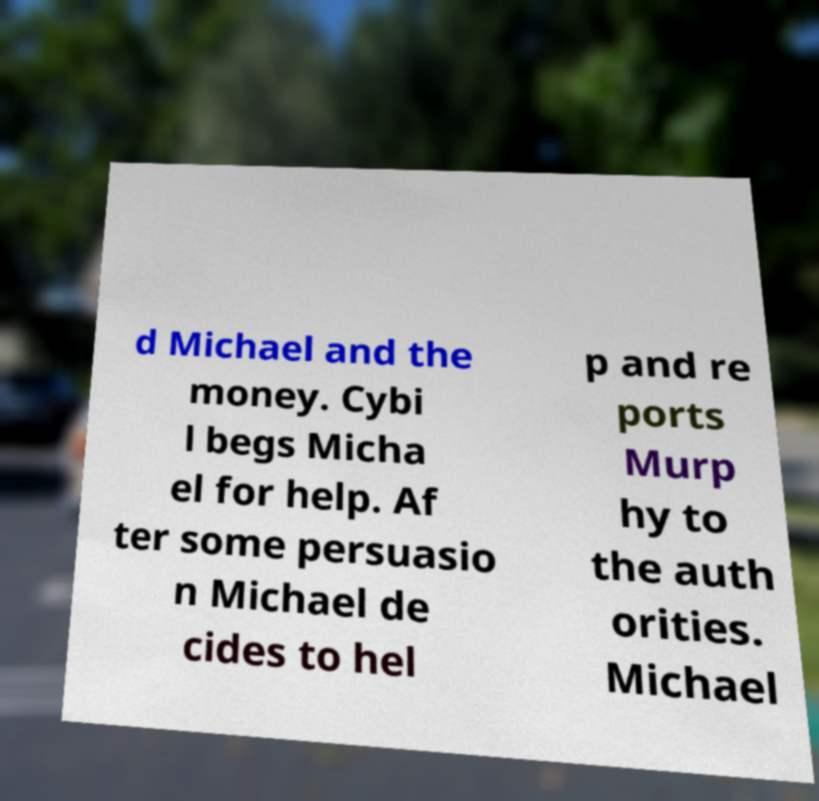Please identify and transcribe the text found in this image. d Michael and the money. Cybi l begs Micha el for help. Af ter some persuasio n Michael de cides to hel p and re ports Murp hy to the auth orities. Michael 